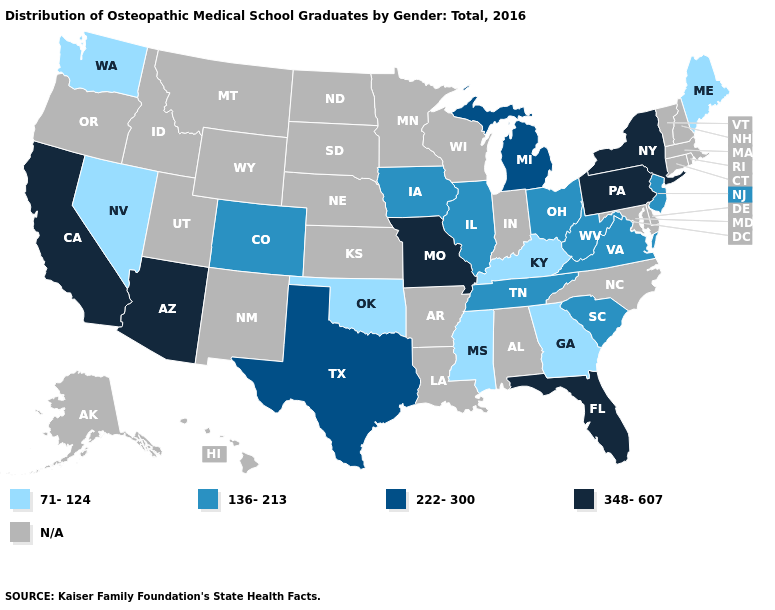Does the map have missing data?
Quick response, please. Yes. What is the value of Texas?
Keep it brief. 222-300. How many symbols are there in the legend?
Write a very short answer. 5. Does Texas have the highest value in the USA?
Answer briefly. No. What is the lowest value in the USA?
Write a very short answer. 71-124. Name the states that have a value in the range 71-124?
Answer briefly. Georgia, Kentucky, Maine, Mississippi, Nevada, Oklahoma, Washington. How many symbols are there in the legend?
Keep it brief. 5. Among the states that border North Carolina , which have the highest value?
Concise answer only. South Carolina, Tennessee, Virginia. What is the value of Pennsylvania?
Answer briefly. 348-607. Name the states that have a value in the range 136-213?
Quick response, please. Colorado, Illinois, Iowa, New Jersey, Ohio, South Carolina, Tennessee, Virginia, West Virginia. What is the value of Connecticut?
Answer briefly. N/A. Name the states that have a value in the range 348-607?
Short answer required. Arizona, California, Florida, Missouri, New York, Pennsylvania. Name the states that have a value in the range 71-124?
Short answer required. Georgia, Kentucky, Maine, Mississippi, Nevada, Oklahoma, Washington. 